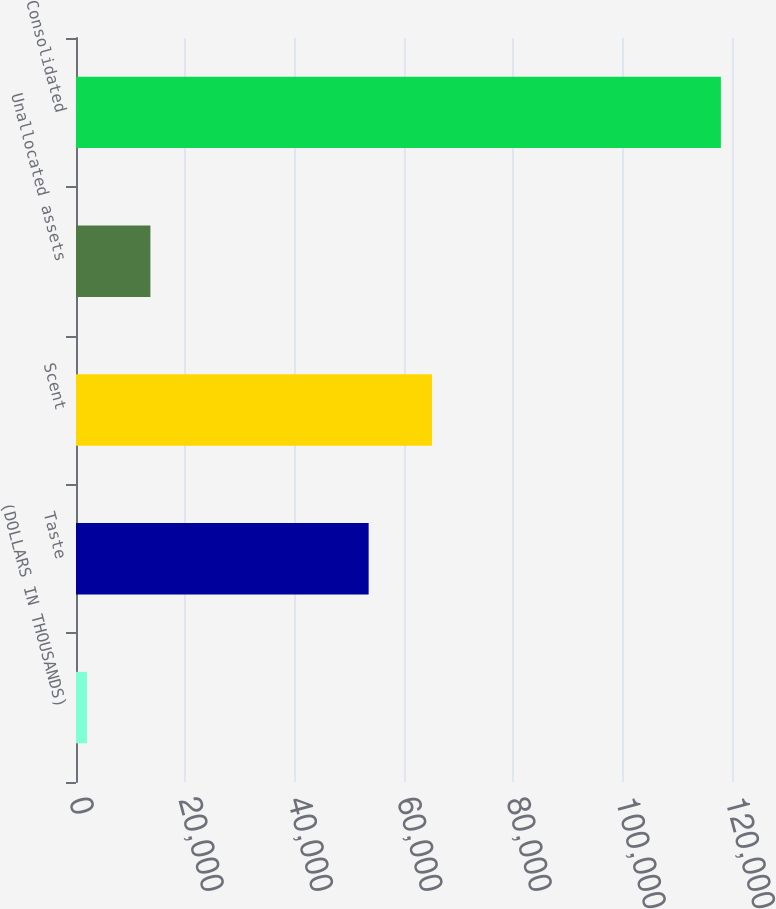Convert chart to OTSL. <chart><loc_0><loc_0><loc_500><loc_500><bar_chart><fcel>(DOLLARS IN THOUSANDS)<fcel>Taste<fcel>Scent<fcel>Unallocated assets<fcel>Consolidated<nl><fcel>2017<fcel>53534<fcel>65129<fcel>13612<fcel>117967<nl></chart> 